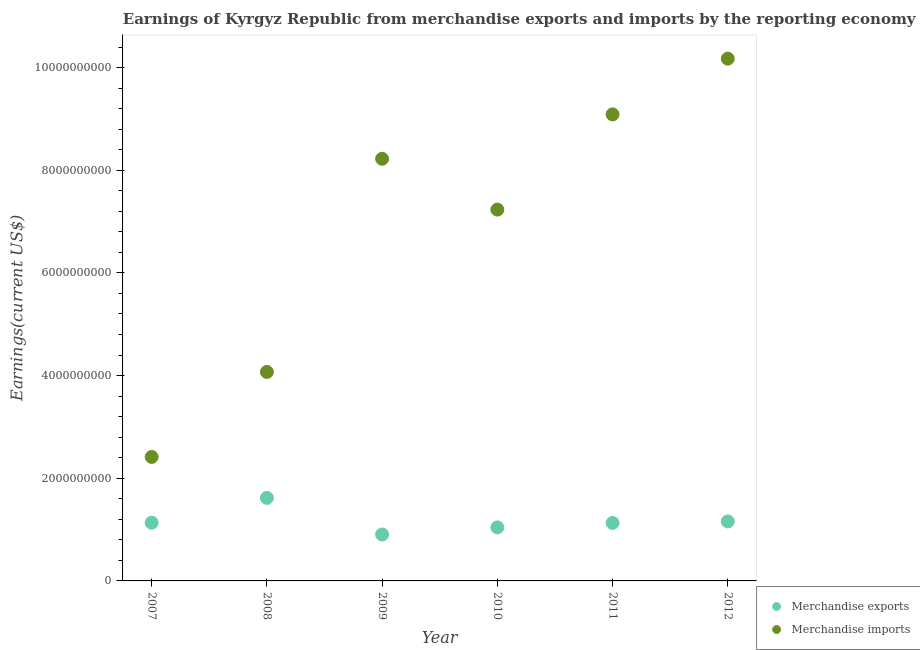What is the earnings from merchandise exports in 2007?
Ensure brevity in your answer.  1.13e+09. Across all years, what is the maximum earnings from merchandise imports?
Your answer should be very brief. 1.02e+1. Across all years, what is the minimum earnings from merchandise exports?
Keep it short and to the point. 9.04e+08. What is the total earnings from merchandise imports in the graph?
Offer a terse response. 4.12e+1. What is the difference between the earnings from merchandise exports in 2008 and that in 2012?
Your answer should be very brief. 4.58e+08. What is the difference between the earnings from merchandise imports in 2012 and the earnings from merchandise exports in 2009?
Provide a short and direct response. 9.27e+09. What is the average earnings from merchandise imports per year?
Provide a short and direct response. 6.87e+09. In the year 2009, what is the difference between the earnings from merchandise exports and earnings from merchandise imports?
Offer a very short reply. -7.32e+09. What is the ratio of the earnings from merchandise imports in 2007 to that in 2009?
Your answer should be compact. 0.29. Is the difference between the earnings from merchandise imports in 2008 and 2011 greater than the difference between the earnings from merchandise exports in 2008 and 2011?
Offer a terse response. No. What is the difference between the highest and the second highest earnings from merchandise exports?
Ensure brevity in your answer.  4.58e+08. What is the difference between the highest and the lowest earnings from merchandise exports?
Your answer should be compact. 7.13e+08. Does the earnings from merchandise imports monotonically increase over the years?
Provide a succinct answer. No. Is the earnings from merchandise imports strictly greater than the earnings from merchandise exports over the years?
Ensure brevity in your answer.  Yes. How many dotlines are there?
Provide a succinct answer. 2. How many years are there in the graph?
Offer a very short reply. 6. Are the values on the major ticks of Y-axis written in scientific E-notation?
Offer a very short reply. No. Does the graph contain grids?
Make the answer very short. No. Where does the legend appear in the graph?
Make the answer very short. Bottom right. How many legend labels are there?
Make the answer very short. 2. What is the title of the graph?
Your answer should be compact. Earnings of Kyrgyz Republic from merchandise exports and imports by the reporting economy. What is the label or title of the Y-axis?
Ensure brevity in your answer.  Earnings(current US$). What is the Earnings(current US$) in Merchandise exports in 2007?
Ensure brevity in your answer.  1.13e+09. What is the Earnings(current US$) of Merchandise imports in 2007?
Your answer should be very brief. 2.42e+09. What is the Earnings(current US$) of Merchandise exports in 2008?
Offer a terse response. 1.62e+09. What is the Earnings(current US$) of Merchandise imports in 2008?
Make the answer very short. 4.07e+09. What is the Earnings(current US$) in Merchandise exports in 2009?
Your response must be concise. 9.04e+08. What is the Earnings(current US$) in Merchandise imports in 2009?
Your answer should be very brief. 8.22e+09. What is the Earnings(current US$) of Merchandise exports in 2010?
Keep it short and to the point. 1.04e+09. What is the Earnings(current US$) of Merchandise imports in 2010?
Your answer should be compact. 7.23e+09. What is the Earnings(current US$) of Merchandise exports in 2011?
Offer a very short reply. 1.13e+09. What is the Earnings(current US$) in Merchandise imports in 2011?
Offer a very short reply. 9.09e+09. What is the Earnings(current US$) of Merchandise exports in 2012?
Provide a succinct answer. 1.16e+09. What is the Earnings(current US$) of Merchandise imports in 2012?
Your answer should be very brief. 1.02e+1. Across all years, what is the maximum Earnings(current US$) of Merchandise exports?
Your answer should be very brief. 1.62e+09. Across all years, what is the maximum Earnings(current US$) of Merchandise imports?
Provide a short and direct response. 1.02e+1. Across all years, what is the minimum Earnings(current US$) in Merchandise exports?
Give a very brief answer. 9.04e+08. Across all years, what is the minimum Earnings(current US$) in Merchandise imports?
Keep it short and to the point. 2.42e+09. What is the total Earnings(current US$) in Merchandise exports in the graph?
Your answer should be compact. 6.99e+09. What is the total Earnings(current US$) of Merchandise imports in the graph?
Give a very brief answer. 4.12e+1. What is the difference between the Earnings(current US$) in Merchandise exports in 2007 and that in 2008?
Make the answer very short. -4.83e+08. What is the difference between the Earnings(current US$) in Merchandise imports in 2007 and that in 2008?
Your answer should be compact. -1.66e+09. What is the difference between the Earnings(current US$) in Merchandise exports in 2007 and that in 2009?
Provide a succinct answer. 2.30e+08. What is the difference between the Earnings(current US$) in Merchandise imports in 2007 and that in 2009?
Keep it short and to the point. -5.81e+09. What is the difference between the Earnings(current US$) of Merchandise exports in 2007 and that in 2010?
Ensure brevity in your answer.  9.11e+07. What is the difference between the Earnings(current US$) of Merchandise imports in 2007 and that in 2010?
Provide a short and direct response. -4.82e+09. What is the difference between the Earnings(current US$) of Merchandise exports in 2007 and that in 2011?
Your answer should be compact. 5.14e+06. What is the difference between the Earnings(current US$) in Merchandise imports in 2007 and that in 2011?
Give a very brief answer. -6.67e+09. What is the difference between the Earnings(current US$) of Merchandise exports in 2007 and that in 2012?
Offer a very short reply. -2.50e+07. What is the difference between the Earnings(current US$) of Merchandise imports in 2007 and that in 2012?
Make the answer very short. -7.76e+09. What is the difference between the Earnings(current US$) in Merchandise exports in 2008 and that in 2009?
Ensure brevity in your answer.  7.13e+08. What is the difference between the Earnings(current US$) of Merchandise imports in 2008 and that in 2009?
Provide a succinct answer. -4.15e+09. What is the difference between the Earnings(current US$) in Merchandise exports in 2008 and that in 2010?
Your answer should be compact. 5.74e+08. What is the difference between the Earnings(current US$) of Merchandise imports in 2008 and that in 2010?
Your answer should be compact. -3.16e+09. What is the difference between the Earnings(current US$) of Merchandise exports in 2008 and that in 2011?
Give a very brief answer. 4.89e+08. What is the difference between the Earnings(current US$) in Merchandise imports in 2008 and that in 2011?
Your answer should be compact. -5.02e+09. What is the difference between the Earnings(current US$) in Merchandise exports in 2008 and that in 2012?
Make the answer very short. 4.58e+08. What is the difference between the Earnings(current US$) in Merchandise imports in 2008 and that in 2012?
Give a very brief answer. -6.10e+09. What is the difference between the Earnings(current US$) of Merchandise exports in 2009 and that in 2010?
Provide a short and direct response. -1.39e+08. What is the difference between the Earnings(current US$) in Merchandise imports in 2009 and that in 2010?
Provide a succinct answer. 9.90e+08. What is the difference between the Earnings(current US$) in Merchandise exports in 2009 and that in 2011?
Make the answer very short. -2.25e+08. What is the difference between the Earnings(current US$) in Merchandise imports in 2009 and that in 2011?
Provide a short and direct response. -8.65e+08. What is the difference between the Earnings(current US$) in Merchandise exports in 2009 and that in 2012?
Make the answer very short. -2.55e+08. What is the difference between the Earnings(current US$) in Merchandise imports in 2009 and that in 2012?
Offer a terse response. -1.95e+09. What is the difference between the Earnings(current US$) of Merchandise exports in 2010 and that in 2011?
Your answer should be compact. -8.59e+07. What is the difference between the Earnings(current US$) in Merchandise imports in 2010 and that in 2011?
Provide a short and direct response. -1.86e+09. What is the difference between the Earnings(current US$) in Merchandise exports in 2010 and that in 2012?
Provide a short and direct response. -1.16e+08. What is the difference between the Earnings(current US$) of Merchandise imports in 2010 and that in 2012?
Offer a very short reply. -2.94e+09. What is the difference between the Earnings(current US$) of Merchandise exports in 2011 and that in 2012?
Provide a succinct answer. -3.02e+07. What is the difference between the Earnings(current US$) of Merchandise imports in 2011 and that in 2012?
Give a very brief answer. -1.09e+09. What is the difference between the Earnings(current US$) in Merchandise exports in 2007 and the Earnings(current US$) in Merchandise imports in 2008?
Make the answer very short. -2.94e+09. What is the difference between the Earnings(current US$) in Merchandise exports in 2007 and the Earnings(current US$) in Merchandise imports in 2009?
Your answer should be very brief. -7.09e+09. What is the difference between the Earnings(current US$) in Merchandise exports in 2007 and the Earnings(current US$) in Merchandise imports in 2010?
Your answer should be very brief. -6.10e+09. What is the difference between the Earnings(current US$) in Merchandise exports in 2007 and the Earnings(current US$) in Merchandise imports in 2011?
Provide a succinct answer. -7.95e+09. What is the difference between the Earnings(current US$) of Merchandise exports in 2007 and the Earnings(current US$) of Merchandise imports in 2012?
Offer a terse response. -9.04e+09. What is the difference between the Earnings(current US$) of Merchandise exports in 2008 and the Earnings(current US$) of Merchandise imports in 2009?
Offer a very short reply. -6.61e+09. What is the difference between the Earnings(current US$) of Merchandise exports in 2008 and the Earnings(current US$) of Merchandise imports in 2010?
Your response must be concise. -5.62e+09. What is the difference between the Earnings(current US$) in Merchandise exports in 2008 and the Earnings(current US$) in Merchandise imports in 2011?
Keep it short and to the point. -7.47e+09. What is the difference between the Earnings(current US$) of Merchandise exports in 2008 and the Earnings(current US$) of Merchandise imports in 2012?
Your answer should be compact. -8.56e+09. What is the difference between the Earnings(current US$) in Merchandise exports in 2009 and the Earnings(current US$) in Merchandise imports in 2010?
Your answer should be very brief. -6.33e+09. What is the difference between the Earnings(current US$) in Merchandise exports in 2009 and the Earnings(current US$) in Merchandise imports in 2011?
Provide a succinct answer. -8.18e+09. What is the difference between the Earnings(current US$) in Merchandise exports in 2009 and the Earnings(current US$) in Merchandise imports in 2012?
Provide a short and direct response. -9.27e+09. What is the difference between the Earnings(current US$) in Merchandise exports in 2010 and the Earnings(current US$) in Merchandise imports in 2011?
Offer a very short reply. -8.05e+09. What is the difference between the Earnings(current US$) of Merchandise exports in 2010 and the Earnings(current US$) of Merchandise imports in 2012?
Give a very brief answer. -9.13e+09. What is the difference between the Earnings(current US$) in Merchandise exports in 2011 and the Earnings(current US$) in Merchandise imports in 2012?
Provide a succinct answer. -9.05e+09. What is the average Earnings(current US$) in Merchandise exports per year?
Make the answer very short. 1.16e+09. What is the average Earnings(current US$) in Merchandise imports per year?
Keep it short and to the point. 6.87e+09. In the year 2007, what is the difference between the Earnings(current US$) of Merchandise exports and Earnings(current US$) of Merchandise imports?
Your response must be concise. -1.28e+09. In the year 2008, what is the difference between the Earnings(current US$) in Merchandise exports and Earnings(current US$) in Merchandise imports?
Offer a terse response. -2.45e+09. In the year 2009, what is the difference between the Earnings(current US$) of Merchandise exports and Earnings(current US$) of Merchandise imports?
Keep it short and to the point. -7.32e+09. In the year 2010, what is the difference between the Earnings(current US$) of Merchandise exports and Earnings(current US$) of Merchandise imports?
Offer a very short reply. -6.19e+09. In the year 2011, what is the difference between the Earnings(current US$) in Merchandise exports and Earnings(current US$) in Merchandise imports?
Your response must be concise. -7.96e+09. In the year 2012, what is the difference between the Earnings(current US$) of Merchandise exports and Earnings(current US$) of Merchandise imports?
Offer a terse response. -9.01e+09. What is the ratio of the Earnings(current US$) in Merchandise exports in 2007 to that in 2008?
Provide a succinct answer. 0.7. What is the ratio of the Earnings(current US$) of Merchandise imports in 2007 to that in 2008?
Make the answer very short. 0.59. What is the ratio of the Earnings(current US$) of Merchandise exports in 2007 to that in 2009?
Keep it short and to the point. 1.25. What is the ratio of the Earnings(current US$) of Merchandise imports in 2007 to that in 2009?
Your answer should be very brief. 0.29. What is the ratio of the Earnings(current US$) in Merchandise exports in 2007 to that in 2010?
Offer a terse response. 1.09. What is the ratio of the Earnings(current US$) in Merchandise imports in 2007 to that in 2010?
Provide a short and direct response. 0.33. What is the ratio of the Earnings(current US$) of Merchandise imports in 2007 to that in 2011?
Give a very brief answer. 0.27. What is the ratio of the Earnings(current US$) of Merchandise exports in 2007 to that in 2012?
Provide a short and direct response. 0.98. What is the ratio of the Earnings(current US$) of Merchandise imports in 2007 to that in 2012?
Your answer should be very brief. 0.24. What is the ratio of the Earnings(current US$) of Merchandise exports in 2008 to that in 2009?
Give a very brief answer. 1.79. What is the ratio of the Earnings(current US$) of Merchandise imports in 2008 to that in 2009?
Ensure brevity in your answer.  0.5. What is the ratio of the Earnings(current US$) in Merchandise exports in 2008 to that in 2010?
Keep it short and to the point. 1.55. What is the ratio of the Earnings(current US$) of Merchandise imports in 2008 to that in 2010?
Make the answer very short. 0.56. What is the ratio of the Earnings(current US$) of Merchandise exports in 2008 to that in 2011?
Ensure brevity in your answer.  1.43. What is the ratio of the Earnings(current US$) in Merchandise imports in 2008 to that in 2011?
Keep it short and to the point. 0.45. What is the ratio of the Earnings(current US$) in Merchandise exports in 2008 to that in 2012?
Your response must be concise. 1.4. What is the ratio of the Earnings(current US$) of Merchandise imports in 2008 to that in 2012?
Your answer should be very brief. 0.4. What is the ratio of the Earnings(current US$) of Merchandise exports in 2009 to that in 2010?
Give a very brief answer. 0.87. What is the ratio of the Earnings(current US$) of Merchandise imports in 2009 to that in 2010?
Your response must be concise. 1.14. What is the ratio of the Earnings(current US$) in Merchandise exports in 2009 to that in 2011?
Offer a very short reply. 0.8. What is the ratio of the Earnings(current US$) of Merchandise imports in 2009 to that in 2011?
Your answer should be compact. 0.9. What is the ratio of the Earnings(current US$) in Merchandise exports in 2009 to that in 2012?
Provide a short and direct response. 0.78. What is the ratio of the Earnings(current US$) in Merchandise imports in 2009 to that in 2012?
Keep it short and to the point. 0.81. What is the ratio of the Earnings(current US$) in Merchandise exports in 2010 to that in 2011?
Offer a terse response. 0.92. What is the ratio of the Earnings(current US$) of Merchandise imports in 2010 to that in 2011?
Your answer should be compact. 0.8. What is the ratio of the Earnings(current US$) in Merchandise exports in 2010 to that in 2012?
Ensure brevity in your answer.  0.9. What is the ratio of the Earnings(current US$) of Merchandise imports in 2010 to that in 2012?
Provide a succinct answer. 0.71. What is the ratio of the Earnings(current US$) of Merchandise imports in 2011 to that in 2012?
Your response must be concise. 0.89. What is the difference between the highest and the second highest Earnings(current US$) in Merchandise exports?
Offer a terse response. 4.58e+08. What is the difference between the highest and the second highest Earnings(current US$) in Merchandise imports?
Make the answer very short. 1.09e+09. What is the difference between the highest and the lowest Earnings(current US$) in Merchandise exports?
Your answer should be very brief. 7.13e+08. What is the difference between the highest and the lowest Earnings(current US$) of Merchandise imports?
Your answer should be compact. 7.76e+09. 